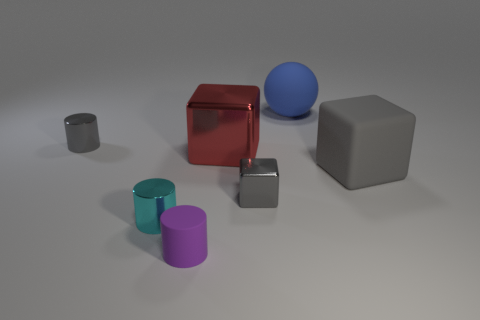What is the color of the other metal thing that is the same shape as the tiny cyan shiny object?
Make the answer very short. Gray. Is there any other thing that is the same shape as the big blue matte object?
Make the answer very short. No. There is a gray matte thing; does it have the same shape as the tiny gray metallic object that is left of the small matte cylinder?
Offer a terse response. No. What is the red object made of?
Ensure brevity in your answer.  Metal. There is another metal thing that is the same shape as the large red shiny thing; what size is it?
Your response must be concise. Small. What number of other objects are the same material as the red object?
Your answer should be compact. 3. Does the cyan object have the same material as the ball behind the cyan metallic object?
Your answer should be compact. No. Is the number of large gray rubber blocks behind the large gray object less than the number of gray shiny cylinders in front of the blue rubber thing?
Your answer should be very brief. Yes. There is a metallic cylinder that is to the left of the tiny cyan cylinder; what is its color?
Give a very brief answer. Gray. How many other things are the same color as the rubber ball?
Offer a very short reply. 0. 